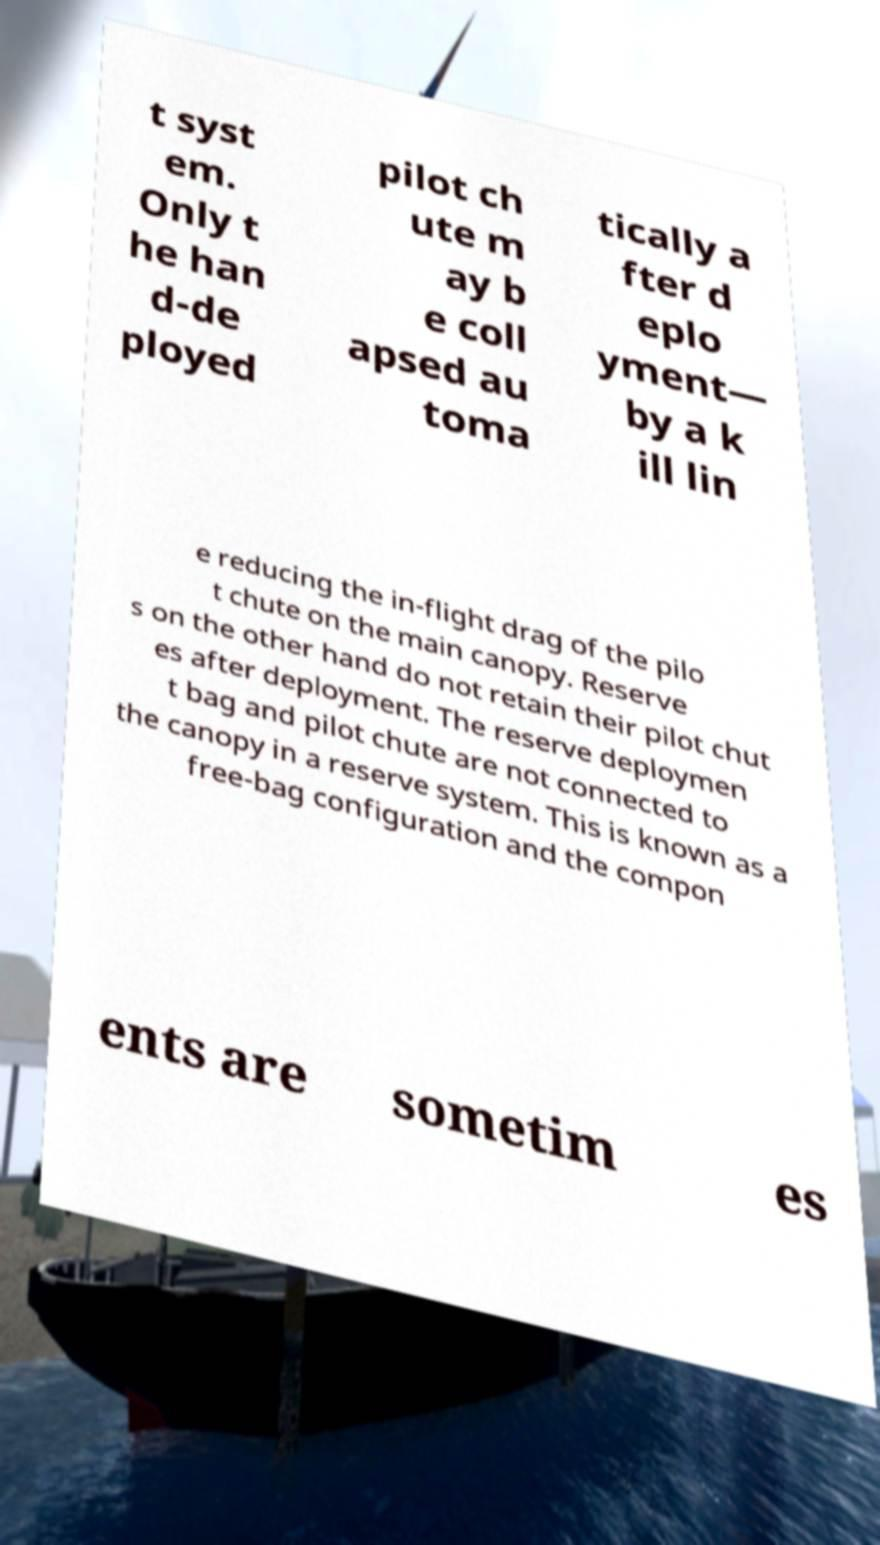Please read and relay the text visible in this image. What does it say? t syst em. Only t he han d-de ployed pilot ch ute m ay b e coll apsed au toma tically a fter d eplo yment— by a k ill lin e reducing the in-flight drag of the pilo t chute on the main canopy. Reserve s on the other hand do not retain their pilot chut es after deployment. The reserve deploymen t bag and pilot chute are not connected to the canopy in a reserve system. This is known as a free-bag configuration and the compon ents are sometim es 